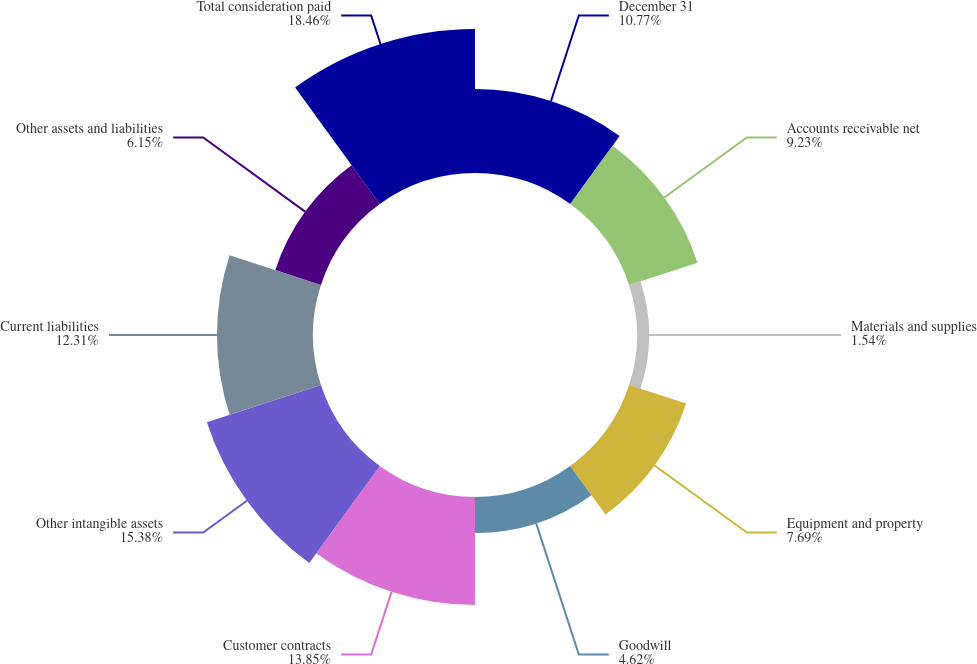Convert chart to OTSL. <chart><loc_0><loc_0><loc_500><loc_500><pie_chart><fcel>December 31<fcel>Accounts receivable net<fcel>Materials and supplies<fcel>Equipment and property<fcel>Goodwill<fcel>Customer contracts<fcel>Other intangible assets<fcel>Current liabilities<fcel>Other assets and liabilities<fcel>Total consideration paid<nl><fcel>10.77%<fcel>9.23%<fcel>1.54%<fcel>7.69%<fcel>4.62%<fcel>13.85%<fcel>15.38%<fcel>12.31%<fcel>6.15%<fcel>18.46%<nl></chart> 